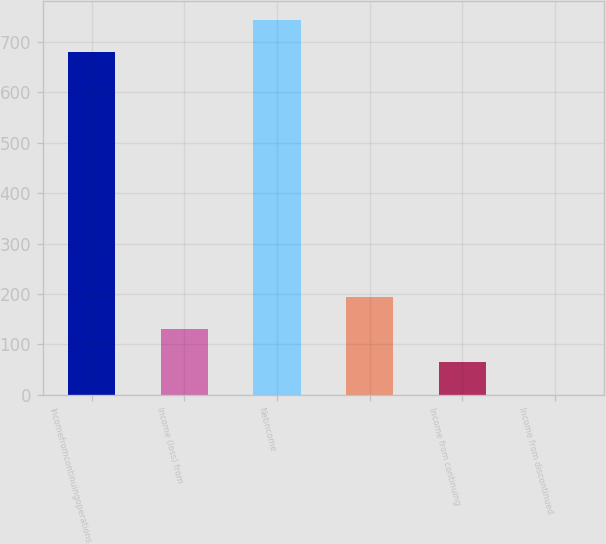Convert chart to OTSL. <chart><loc_0><loc_0><loc_500><loc_500><bar_chart><fcel>Incomefromcontinuingoperations<fcel>Income (loss) from<fcel>Netincome<fcel>Unnamed: 3<fcel>Income from continuing<fcel>Income from discontinued<nl><fcel>679.79<fcel>129.65<fcel>744.58<fcel>194.44<fcel>64.86<fcel>0.07<nl></chart> 